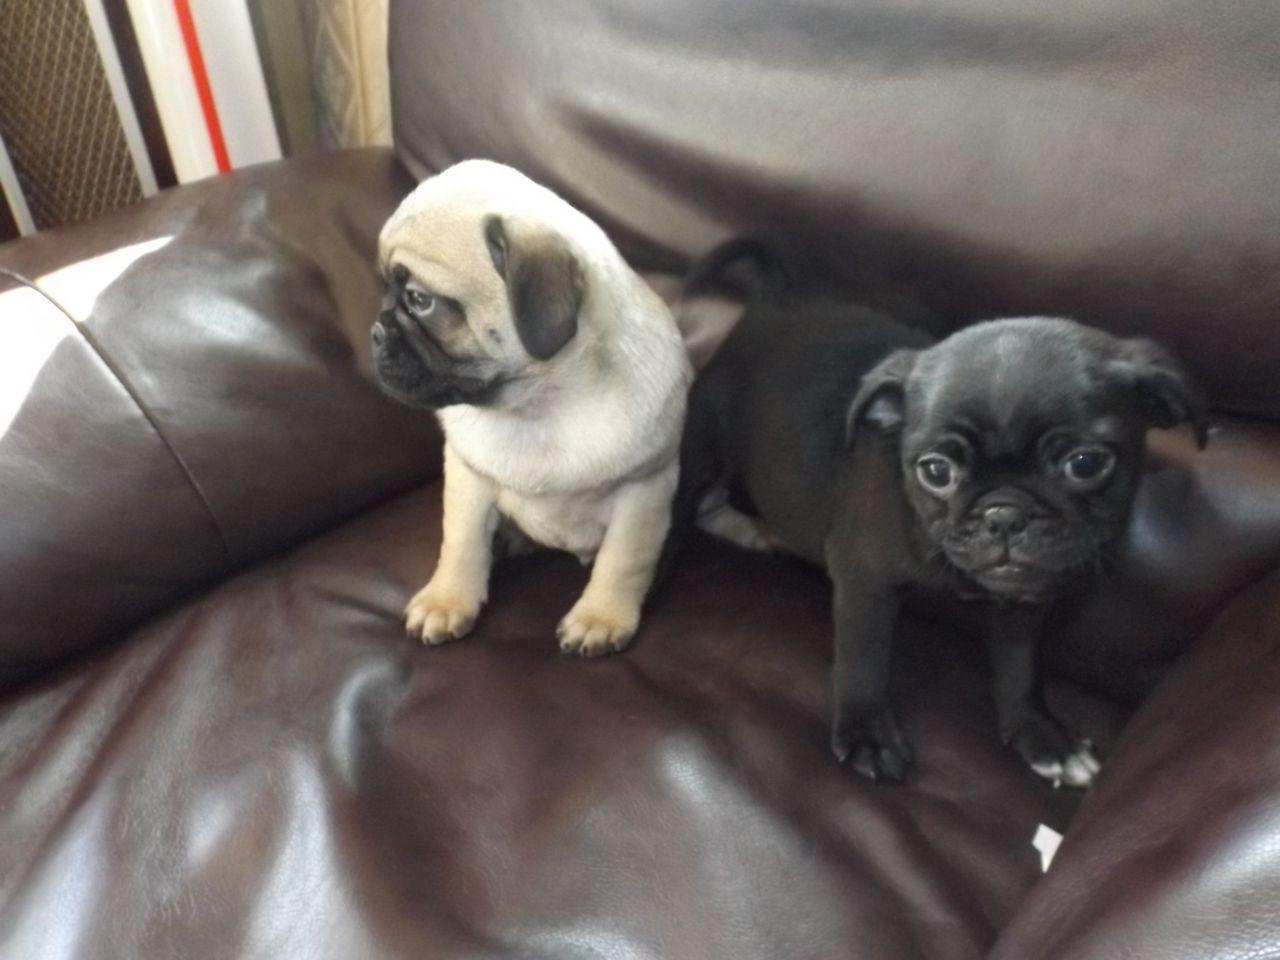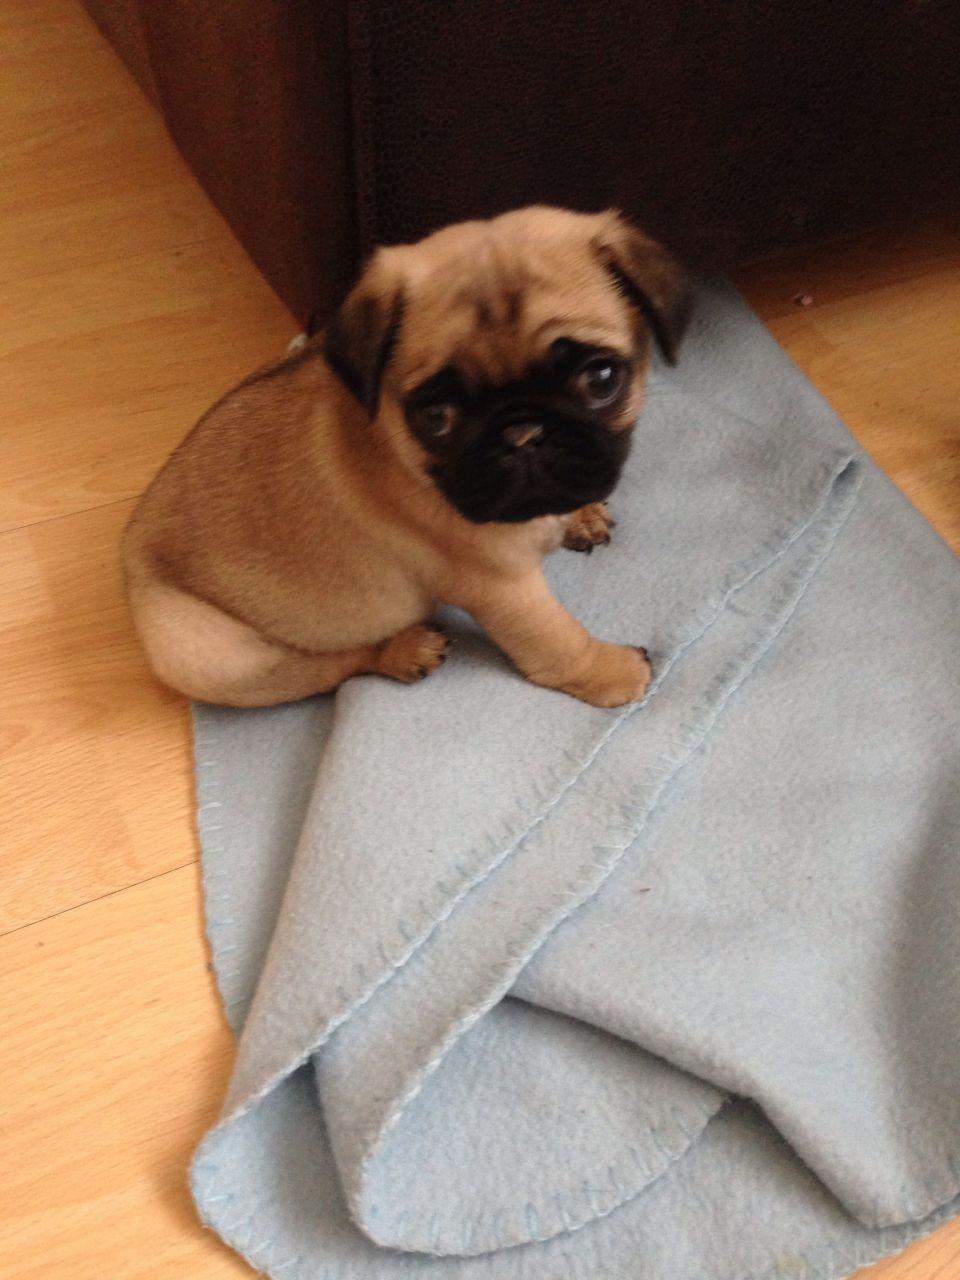The first image is the image on the left, the second image is the image on the right. Considering the images on both sides, is "An image shows just one pug dog on a leather-type seat." valid? Answer yes or no. No. The first image is the image on the left, the second image is the image on the right. Considering the images on both sides, is "A dog is sitting on a shiny seat in the image on the right." valid? Answer yes or no. No. 